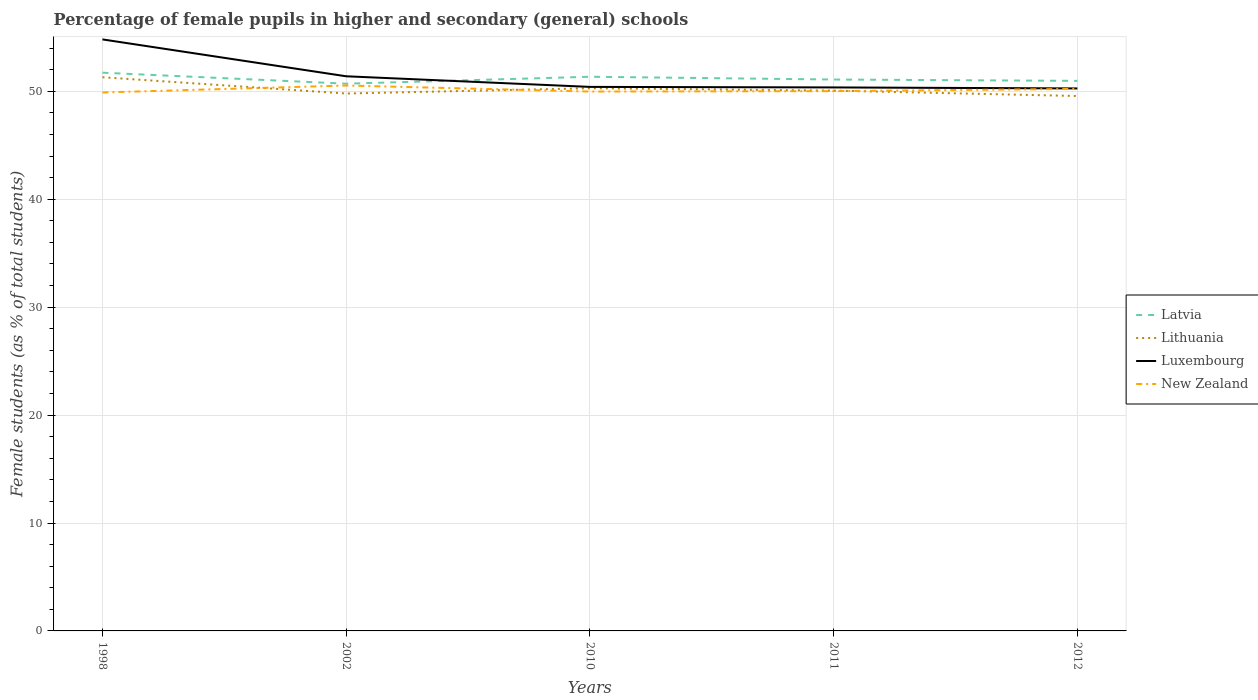How many different coloured lines are there?
Offer a terse response. 4. Does the line corresponding to Lithuania intersect with the line corresponding to Luxembourg?
Ensure brevity in your answer.  No. Across all years, what is the maximum percentage of female pupils in higher and secondary schools in Latvia?
Provide a succinct answer. 50.71. What is the total percentage of female pupils in higher and secondary schools in Latvia in the graph?
Your response must be concise. 0.38. What is the difference between the highest and the second highest percentage of female pupils in higher and secondary schools in New Zealand?
Your response must be concise. 0.65. How many lines are there?
Your answer should be compact. 4. How many years are there in the graph?
Provide a short and direct response. 5. Does the graph contain any zero values?
Provide a short and direct response. No. How are the legend labels stacked?
Ensure brevity in your answer.  Vertical. What is the title of the graph?
Provide a succinct answer. Percentage of female pupils in higher and secondary (general) schools. What is the label or title of the X-axis?
Give a very brief answer. Years. What is the label or title of the Y-axis?
Keep it short and to the point. Female students (as % of total students). What is the Female students (as % of total students) of Latvia in 1998?
Provide a succinct answer. 51.73. What is the Female students (as % of total students) in Lithuania in 1998?
Provide a succinct answer. 51.31. What is the Female students (as % of total students) in Luxembourg in 1998?
Give a very brief answer. 54.81. What is the Female students (as % of total students) of New Zealand in 1998?
Keep it short and to the point. 49.89. What is the Female students (as % of total students) of Latvia in 2002?
Ensure brevity in your answer.  50.71. What is the Female students (as % of total students) of Lithuania in 2002?
Make the answer very short. 49.8. What is the Female students (as % of total students) of Luxembourg in 2002?
Your answer should be compact. 51.39. What is the Female students (as % of total students) of New Zealand in 2002?
Ensure brevity in your answer.  50.54. What is the Female students (as % of total students) in Latvia in 2010?
Offer a terse response. 51.35. What is the Female students (as % of total students) of Lithuania in 2010?
Provide a short and direct response. 50.29. What is the Female students (as % of total students) of Luxembourg in 2010?
Ensure brevity in your answer.  50.41. What is the Female students (as % of total students) in New Zealand in 2010?
Your answer should be very brief. 49.98. What is the Female students (as % of total students) in Latvia in 2011?
Your answer should be compact. 51.09. What is the Female students (as % of total students) in Lithuania in 2011?
Offer a very short reply. 50.06. What is the Female students (as % of total students) in Luxembourg in 2011?
Your answer should be compact. 50.36. What is the Female students (as % of total students) in New Zealand in 2011?
Offer a very short reply. 50.02. What is the Female students (as % of total students) of Latvia in 2012?
Your response must be concise. 50.97. What is the Female students (as % of total students) of Lithuania in 2012?
Offer a very short reply. 49.56. What is the Female students (as % of total students) in Luxembourg in 2012?
Make the answer very short. 50.27. What is the Female students (as % of total students) of New Zealand in 2012?
Make the answer very short. 50.22. Across all years, what is the maximum Female students (as % of total students) in Latvia?
Your answer should be compact. 51.73. Across all years, what is the maximum Female students (as % of total students) of Lithuania?
Offer a terse response. 51.31. Across all years, what is the maximum Female students (as % of total students) of Luxembourg?
Your response must be concise. 54.81. Across all years, what is the maximum Female students (as % of total students) of New Zealand?
Provide a succinct answer. 50.54. Across all years, what is the minimum Female students (as % of total students) of Latvia?
Provide a short and direct response. 50.71. Across all years, what is the minimum Female students (as % of total students) in Lithuania?
Your answer should be very brief. 49.56. Across all years, what is the minimum Female students (as % of total students) in Luxembourg?
Your response must be concise. 50.27. Across all years, what is the minimum Female students (as % of total students) of New Zealand?
Give a very brief answer. 49.89. What is the total Female students (as % of total students) of Latvia in the graph?
Offer a very short reply. 255.84. What is the total Female students (as % of total students) of Lithuania in the graph?
Offer a terse response. 251.02. What is the total Female students (as % of total students) in Luxembourg in the graph?
Offer a very short reply. 257.24. What is the total Female students (as % of total students) of New Zealand in the graph?
Make the answer very short. 250.65. What is the difference between the Female students (as % of total students) of Latvia in 1998 and that in 2002?
Ensure brevity in your answer.  1.02. What is the difference between the Female students (as % of total students) in Lithuania in 1998 and that in 2002?
Give a very brief answer. 1.51. What is the difference between the Female students (as % of total students) in Luxembourg in 1998 and that in 2002?
Your answer should be very brief. 3.42. What is the difference between the Female students (as % of total students) of New Zealand in 1998 and that in 2002?
Make the answer very short. -0.65. What is the difference between the Female students (as % of total students) in Latvia in 1998 and that in 2010?
Give a very brief answer. 0.38. What is the difference between the Female students (as % of total students) in Lithuania in 1998 and that in 2010?
Ensure brevity in your answer.  1.02. What is the difference between the Female students (as % of total students) in Luxembourg in 1998 and that in 2010?
Offer a very short reply. 4.4. What is the difference between the Female students (as % of total students) in New Zealand in 1998 and that in 2010?
Your answer should be very brief. -0.09. What is the difference between the Female students (as % of total students) of Latvia in 1998 and that in 2011?
Keep it short and to the point. 0.63. What is the difference between the Female students (as % of total students) of Lithuania in 1998 and that in 2011?
Offer a terse response. 1.24. What is the difference between the Female students (as % of total students) of Luxembourg in 1998 and that in 2011?
Provide a succinct answer. 4.45. What is the difference between the Female students (as % of total students) of New Zealand in 1998 and that in 2011?
Keep it short and to the point. -0.12. What is the difference between the Female students (as % of total students) in Latvia in 1998 and that in 2012?
Your response must be concise. 0.76. What is the difference between the Female students (as % of total students) of Lithuania in 1998 and that in 2012?
Provide a short and direct response. 1.74. What is the difference between the Female students (as % of total students) in Luxembourg in 1998 and that in 2012?
Ensure brevity in your answer.  4.54. What is the difference between the Female students (as % of total students) in New Zealand in 1998 and that in 2012?
Ensure brevity in your answer.  -0.33. What is the difference between the Female students (as % of total students) of Latvia in 2002 and that in 2010?
Offer a very short reply. -0.64. What is the difference between the Female students (as % of total students) in Lithuania in 2002 and that in 2010?
Provide a succinct answer. -0.49. What is the difference between the Female students (as % of total students) of Luxembourg in 2002 and that in 2010?
Give a very brief answer. 0.98. What is the difference between the Female students (as % of total students) in New Zealand in 2002 and that in 2010?
Provide a succinct answer. 0.56. What is the difference between the Female students (as % of total students) of Latvia in 2002 and that in 2011?
Your response must be concise. -0.39. What is the difference between the Female students (as % of total students) of Lithuania in 2002 and that in 2011?
Ensure brevity in your answer.  -0.27. What is the difference between the Female students (as % of total students) of Luxembourg in 2002 and that in 2011?
Your answer should be very brief. 1.03. What is the difference between the Female students (as % of total students) in New Zealand in 2002 and that in 2011?
Give a very brief answer. 0.52. What is the difference between the Female students (as % of total students) in Latvia in 2002 and that in 2012?
Your answer should be compact. -0.26. What is the difference between the Female students (as % of total students) of Lithuania in 2002 and that in 2012?
Give a very brief answer. 0.23. What is the difference between the Female students (as % of total students) in Luxembourg in 2002 and that in 2012?
Ensure brevity in your answer.  1.13. What is the difference between the Female students (as % of total students) of New Zealand in 2002 and that in 2012?
Offer a terse response. 0.32. What is the difference between the Female students (as % of total students) in Latvia in 2010 and that in 2011?
Provide a succinct answer. 0.26. What is the difference between the Female students (as % of total students) in Lithuania in 2010 and that in 2011?
Offer a terse response. 0.22. What is the difference between the Female students (as % of total students) of Luxembourg in 2010 and that in 2011?
Make the answer very short. 0.05. What is the difference between the Female students (as % of total students) in New Zealand in 2010 and that in 2011?
Your answer should be very brief. -0.04. What is the difference between the Female students (as % of total students) in Latvia in 2010 and that in 2012?
Keep it short and to the point. 0.38. What is the difference between the Female students (as % of total students) of Lithuania in 2010 and that in 2012?
Offer a terse response. 0.72. What is the difference between the Female students (as % of total students) in Luxembourg in 2010 and that in 2012?
Make the answer very short. 0.14. What is the difference between the Female students (as % of total students) of New Zealand in 2010 and that in 2012?
Provide a succinct answer. -0.24. What is the difference between the Female students (as % of total students) in Latvia in 2011 and that in 2012?
Offer a terse response. 0.12. What is the difference between the Female students (as % of total students) of Lithuania in 2011 and that in 2012?
Offer a terse response. 0.5. What is the difference between the Female students (as % of total students) of Luxembourg in 2011 and that in 2012?
Provide a short and direct response. 0.09. What is the difference between the Female students (as % of total students) in New Zealand in 2011 and that in 2012?
Offer a terse response. -0.21. What is the difference between the Female students (as % of total students) of Latvia in 1998 and the Female students (as % of total students) of Lithuania in 2002?
Offer a terse response. 1.93. What is the difference between the Female students (as % of total students) of Latvia in 1998 and the Female students (as % of total students) of Luxembourg in 2002?
Offer a terse response. 0.33. What is the difference between the Female students (as % of total students) in Latvia in 1998 and the Female students (as % of total students) in New Zealand in 2002?
Provide a short and direct response. 1.19. What is the difference between the Female students (as % of total students) in Lithuania in 1998 and the Female students (as % of total students) in Luxembourg in 2002?
Offer a terse response. -0.09. What is the difference between the Female students (as % of total students) in Lithuania in 1998 and the Female students (as % of total students) in New Zealand in 2002?
Offer a terse response. 0.77. What is the difference between the Female students (as % of total students) of Luxembourg in 1998 and the Female students (as % of total students) of New Zealand in 2002?
Offer a terse response. 4.27. What is the difference between the Female students (as % of total students) in Latvia in 1998 and the Female students (as % of total students) in Lithuania in 2010?
Make the answer very short. 1.44. What is the difference between the Female students (as % of total students) in Latvia in 1998 and the Female students (as % of total students) in Luxembourg in 2010?
Offer a terse response. 1.32. What is the difference between the Female students (as % of total students) in Latvia in 1998 and the Female students (as % of total students) in New Zealand in 2010?
Offer a terse response. 1.75. What is the difference between the Female students (as % of total students) of Lithuania in 1998 and the Female students (as % of total students) of Luxembourg in 2010?
Your response must be concise. 0.9. What is the difference between the Female students (as % of total students) of Lithuania in 1998 and the Female students (as % of total students) of New Zealand in 2010?
Give a very brief answer. 1.33. What is the difference between the Female students (as % of total students) of Luxembourg in 1998 and the Female students (as % of total students) of New Zealand in 2010?
Give a very brief answer. 4.83. What is the difference between the Female students (as % of total students) of Latvia in 1998 and the Female students (as % of total students) of Lithuania in 2011?
Your response must be concise. 1.66. What is the difference between the Female students (as % of total students) of Latvia in 1998 and the Female students (as % of total students) of Luxembourg in 2011?
Make the answer very short. 1.36. What is the difference between the Female students (as % of total students) in Latvia in 1998 and the Female students (as % of total students) in New Zealand in 2011?
Provide a short and direct response. 1.71. What is the difference between the Female students (as % of total students) of Lithuania in 1998 and the Female students (as % of total students) of Luxembourg in 2011?
Offer a terse response. 0.94. What is the difference between the Female students (as % of total students) in Lithuania in 1998 and the Female students (as % of total students) in New Zealand in 2011?
Make the answer very short. 1.29. What is the difference between the Female students (as % of total students) of Luxembourg in 1998 and the Female students (as % of total students) of New Zealand in 2011?
Provide a succinct answer. 4.79. What is the difference between the Female students (as % of total students) of Latvia in 1998 and the Female students (as % of total students) of Lithuania in 2012?
Provide a succinct answer. 2.16. What is the difference between the Female students (as % of total students) in Latvia in 1998 and the Female students (as % of total students) in Luxembourg in 2012?
Your response must be concise. 1.46. What is the difference between the Female students (as % of total students) in Latvia in 1998 and the Female students (as % of total students) in New Zealand in 2012?
Provide a succinct answer. 1.5. What is the difference between the Female students (as % of total students) in Lithuania in 1998 and the Female students (as % of total students) in Luxembourg in 2012?
Keep it short and to the point. 1.04. What is the difference between the Female students (as % of total students) of Lithuania in 1998 and the Female students (as % of total students) of New Zealand in 2012?
Offer a very short reply. 1.08. What is the difference between the Female students (as % of total students) of Luxembourg in 1998 and the Female students (as % of total students) of New Zealand in 2012?
Your answer should be compact. 4.59. What is the difference between the Female students (as % of total students) of Latvia in 2002 and the Female students (as % of total students) of Lithuania in 2010?
Offer a terse response. 0.42. What is the difference between the Female students (as % of total students) of Latvia in 2002 and the Female students (as % of total students) of Luxembourg in 2010?
Keep it short and to the point. 0.3. What is the difference between the Female students (as % of total students) of Latvia in 2002 and the Female students (as % of total students) of New Zealand in 2010?
Your answer should be very brief. 0.73. What is the difference between the Female students (as % of total students) in Lithuania in 2002 and the Female students (as % of total students) in Luxembourg in 2010?
Provide a short and direct response. -0.61. What is the difference between the Female students (as % of total students) in Lithuania in 2002 and the Female students (as % of total students) in New Zealand in 2010?
Make the answer very short. -0.18. What is the difference between the Female students (as % of total students) in Luxembourg in 2002 and the Female students (as % of total students) in New Zealand in 2010?
Provide a succinct answer. 1.41. What is the difference between the Female students (as % of total students) in Latvia in 2002 and the Female students (as % of total students) in Lithuania in 2011?
Make the answer very short. 0.64. What is the difference between the Female students (as % of total students) in Latvia in 2002 and the Female students (as % of total students) in Luxembourg in 2011?
Your answer should be very brief. 0.35. What is the difference between the Female students (as % of total students) of Latvia in 2002 and the Female students (as % of total students) of New Zealand in 2011?
Provide a short and direct response. 0.69. What is the difference between the Female students (as % of total students) in Lithuania in 2002 and the Female students (as % of total students) in Luxembourg in 2011?
Give a very brief answer. -0.57. What is the difference between the Female students (as % of total students) in Lithuania in 2002 and the Female students (as % of total students) in New Zealand in 2011?
Your answer should be very brief. -0.22. What is the difference between the Female students (as % of total students) in Luxembourg in 2002 and the Female students (as % of total students) in New Zealand in 2011?
Your response must be concise. 1.38. What is the difference between the Female students (as % of total students) in Latvia in 2002 and the Female students (as % of total students) in Lithuania in 2012?
Ensure brevity in your answer.  1.14. What is the difference between the Female students (as % of total students) in Latvia in 2002 and the Female students (as % of total students) in Luxembourg in 2012?
Ensure brevity in your answer.  0.44. What is the difference between the Female students (as % of total students) in Latvia in 2002 and the Female students (as % of total students) in New Zealand in 2012?
Ensure brevity in your answer.  0.48. What is the difference between the Female students (as % of total students) in Lithuania in 2002 and the Female students (as % of total students) in Luxembourg in 2012?
Your answer should be compact. -0.47. What is the difference between the Female students (as % of total students) of Lithuania in 2002 and the Female students (as % of total students) of New Zealand in 2012?
Ensure brevity in your answer.  -0.43. What is the difference between the Female students (as % of total students) in Luxembourg in 2002 and the Female students (as % of total students) in New Zealand in 2012?
Offer a terse response. 1.17. What is the difference between the Female students (as % of total students) of Latvia in 2010 and the Female students (as % of total students) of Lithuania in 2011?
Make the answer very short. 1.29. What is the difference between the Female students (as % of total students) in Latvia in 2010 and the Female students (as % of total students) in New Zealand in 2011?
Make the answer very short. 1.33. What is the difference between the Female students (as % of total students) of Lithuania in 2010 and the Female students (as % of total students) of Luxembourg in 2011?
Your answer should be compact. -0.07. What is the difference between the Female students (as % of total students) in Lithuania in 2010 and the Female students (as % of total students) in New Zealand in 2011?
Your answer should be compact. 0.27. What is the difference between the Female students (as % of total students) in Luxembourg in 2010 and the Female students (as % of total students) in New Zealand in 2011?
Give a very brief answer. 0.39. What is the difference between the Female students (as % of total students) of Latvia in 2010 and the Female students (as % of total students) of Lithuania in 2012?
Your answer should be very brief. 1.78. What is the difference between the Female students (as % of total students) of Latvia in 2010 and the Female students (as % of total students) of Luxembourg in 2012?
Offer a terse response. 1.08. What is the difference between the Female students (as % of total students) in Latvia in 2010 and the Female students (as % of total students) in New Zealand in 2012?
Offer a terse response. 1.13. What is the difference between the Female students (as % of total students) in Lithuania in 2010 and the Female students (as % of total students) in Luxembourg in 2012?
Keep it short and to the point. 0.02. What is the difference between the Female students (as % of total students) in Lithuania in 2010 and the Female students (as % of total students) in New Zealand in 2012?
Your answer should be very brief. 0.06. What is the difference between the Female students (as % of total students) in Luxembourg in 2010 and the Female students (as % of total students) in New Zealand in 2012?
Keep it short and to the point. 0.19. What is the difference between the Female students (as % of total students) of Latvia in 2011 and the Female students (as % of total students) of Lithuania in 2012?
Your response must be concise. 1.53. What is the difference between the Female students (as % of total students) in Latvia in 2011 and the Female students (as % of total students) in Luxembourg in 2012?
Give a very brief answer. 0.83. What is the difference between the Female students (as % of total students) in Latvia in 2011 and the Female students (as % of total students) in New Zealand in 2012?
Your answer should be compact. 0.87. What is the difference between the Female students (as % of total students) of Lithuania in 2011 and the Female students (as % of total students) of Luxembourg in 2012?
Offer a very short reply. -0.2. What is the difference between the Female students (as % of total students) in Lithuania in 2011 and the Female students (as % of total students) in New Zealand in 2012?
Make the answer very short. -0.16. What is the difference between the Female students (as % of total students) of Luxembourg in 2011 and the Female students (as % of total students) of New Zealand in 2012?
Your answer should be very brief. 0.14. What is the average Female students (as % of total students) in Latvia per year?
Provide a short and direct response. 51.17. What is the average Female students (as % of total students) in Lithuania per year?
Your answer should be very brief. 50.2. What is the average Female students (as % of total students) in Luxembourg per year?
Offer a terse response. 51.45. What is the average Female students (as % of total students) of New Zealand per year?
Your answer should be very brief. 50.13. In the year 1998, what is the difference between the Female students (as % of total students) of Latvia and Female students (as % of total students) of Lithuania?
Keep it short and to the point. 0.42. In the year 1998, what is the difference between the Female students (as % of total students) in Latvia and Female students (as % of total students) in Luxembourg?
Provide a succinct answer. -3.08. In the year 1998, what is the difference between the Female students (as % of total students) in Latvia and Female students (as % of total students) in New Zealand?
Provide a short and direct response. 1.83. In the year 1998, what is the difference between the Female students (as % of total students) in Lithuania and Female students (as % of total students) in Luxembourg?
Offer a very short reply. -3.5. In the year 1998, what is the difference between the Female students (as % of total students) of Lithuania and Female students (as % of total students) of New Zealand?
Ensure brevity in your answer.  1.41. In the year 1998, what is the difference between the Female students (as % of total students) in Luxembourg and Female students (as % of total students) in New Zealand?
Provide a succinct answer. 4.92. In the year 2002, what is the difference between the Female students (as % of total students) in Latvia and Female students (as % of total students) in Lithuania?
Your answer should be very brief. 0.91. In the year 2002, what is the difference between the Female students (as % of total students) in Latvia and Female students (as % of total students) in Luxembourg?
Your answer should be very brief. -0.69. In the year 2002, what is the difference between the Female students (as % of total students) in Latvia and Female students (as % of total students) in New Zealand?
Your response must be concise. 0.17. In the year 2002, what is the difference between the Female students (as % of total students) in Lithuania and Female students (as % of total students) in Luxembourg?
Your answer should be compact. -1.6. In the year 2002, what is the difference between the Female students (as % of total students) of Lithuania and Female students (as % of total students) of New Zealand?
Give a very brief answer. -0.74. In the year 2002, what is the difference between the Female students (as % of total students) in Luxembourg and Female students (as % of total students) in New Zealand?
Provide a short and direct response. 0.85. In the year 2010, what is the difference between the Female students (as % of total students) of Latvia and Female students (as % of total students) of Lithuania?
Your response must be concise. 1.06. In the year 2010, what is the difference between the Female students (as % of total students) of Latvia and Female students (as % of total students) of Luxembourg?
Offer a terse response. 0.94. In the year 2010, what is the difference between the Female students (as % of total students) in Latvia and Female students (as % of total students) in New Zealand?
Provide a succinct answer. 1.37. In the year 2010, what is the difference between the Female students (as % of total students) of Lithuania and Female students (as % of total students) of Luxembourg?
Your answer should be compact. -0.12. In the year 2010, what is the difference between the Female students (as % of total students) in Lithuania and Female students (as % of total students) in New Zealand?
Keep it short and to the point. 0.31. In the year 2010, what is the difference between the Female students (as % of total students) in Luxembourg and Female students (as % of total students) in New Zealand?
Give a very brief answer. 0.43. In the year 2011, what is the difference between the Female students (as % of total students) of Latvia and Female students (as % of total students) of Lithuania?
Give a very brief answer. 1.03. In the year 2011, what is the difference between the Female students (as % of total students) of Latvia and Female students (as % of total students) of Luxembourg?
Offer a terse response. 0.73. In the year 2011, what is the difference between the Female students (as % of total students) of Latvia and Female students (as % of total students) of New Zealand?
Keep it short and to the point. 1.08. In the year 2011, what is the difference between the Female students (as % of total students) of Lithuania and Female students (as % of total students) of Luxembourg?
Ensure brevity in your answer.  -0.3. In the year 2011, what is the difference between the Female students (as % of total students) of Lithuania and Female students (as % of total students) of New Zealand?
Make the answer very short. 0.05. In the year 2011, what is the difference between the Female students (as % of total students) of Luxembourg and Female students (as % of total students) of New Zealand?
Provide a succinct answer. 0.35. In the year 2012, what is the difference between the Female students (as % of total students) of Latvia and Female students (as % of total students) of Lithuania?
Ensure brevity in your answer.  1.4. In the year 2012, what is the difference between the Female students (as % of total students) of Latvia and Female students (as % of total students) of Luxembourg?
Offer a very short reply. 0.7. In the year 2012, what is the difference between the Female students (as % of total students) in Latvia and Female students (as % of total students) in New Zealand?
Ensure brevity in your answer.  0.74. In the year 2012, what is the difference between the Female students (as % of total students) in Lithuania and Female students (as % of total students) in Luxembourg?
Offer a terse response. -0.7. In the year 2012, what is the difference between the Female students (as % of total students) of Lithuania and Female students (as % of total students) of New Zealand?
Provide a succinct answer. -0.66. In the year 2012, what is the difference between the Female students (as % of total students) in Luxembourg and Female students (as % of total students) in New Zealand?
Give a very brief answer. 0.04. What is the ratio of the Female students (as % of total students) of Latvia in 1998 to that in 2002?
Your answer should be very brief. 1.02. What is the ratio of the Female students (as % of total students) in Lithuania in 1998 to that in 2002?
Keep it short and to the point. 1.03. What is the ratio of the Female students (as % of total students) of Luxembourg in 1998 to that in 2002?
Offer a terse response. 1.07. What is the ratio of the Female students (as % of total students) of New Zealand in 1998 to that in 2002?
Provide a succinct answer. 0.99. What is the ratio of the Female students (as % of total students) in Latvia in 1998 to that in 2010?
Provide a short and direct response. 1.01. What is the ratio of the Female students (as % of total students) in Lithuania in 1998 to that in 2010?
Your answer should be very brief. 1.02. What is the ratio of the Female students (as % of total students) of Luxembourg in 1998 to that in 2010?
Your answer should be very brief. 1.09. What is the ratio of the Female students (as % of total students) in New Zealand in 1998 to that in 2010?
Give a very brief answer. 1. What is the ratio of the Female students (as % of total students) of Latvia in 1998 to that in 2011?
Keep it short and to the point. 1.01. What is the ratio of the Female students (as % of total students) of Lithuania in 1998 to that in 2011?
Your response must be concise. 1.02. What is the ratio of the Female students (as % of total students) of Luxembourg in 1998 to that in 2011?
Provide a succinct answer. 1.09. What is the ratio of the Female students (as % of total students) of Latvia in 1998 to that in 2012?
Your response must be concise. 1.01. What is the ratio of the Female students (as % of total students) in Lithuania in 1998 to that in 2012?
Provide a succinct answer. 1.04. What is the ratio of the Female students (as % of total students) of Luxembourg in 1998 to that in 2012?
Your answer should be very brief. 1.09. What is the ratio of the Female students (as % of total students) in New Zealand in 1998 to that in 2012?
Your response must be concise. 0.99. What is the ratio of the Female students (as % of total students) of Latvia in 2002 to that in 2010?
Provide a succinct answer. 0.99. What is the ratio of the Female students (as % of total students) in Lithuania in 2002 to that in 2010?
Ensure brevity in your answer.  0.99. What is the ratio of the Female students (as % of total students) in Luxembourg in 2002 to that in 2010?
Your response must be concise. 1.02. What is the ratio of the Female students (as % of total students) of New Zealand in 2002 to that in 2010?
Offer a terse response. 1.01. What is the ratio of the Female students (as % of total students) of Latvia in 2002 to that in 2011?
Your answer should be compact. 0.99. What is the ratio of the Female students (as % of total students) of Luxembourg in 2002 to that in 2011?
Give a very brief answer. 1.02. What is the ratio of the Female students (as % of total students) of New Zealand in 2002 to that in 2011?
Ensure brevity in your answer.  1.01. What is the ratio of the Female students (as % of total students) of Latvia in 2002 to that in 2012?
Provide a succinct answer. 0.99. What is the ratio of the Female students (as % of total students) of Luxembourg in 2002 to that in 2012?
Offer a very short reply. 1.02. What is the ratio of the Female students (as % of total students) in New Zealand in 2002 to that in 2012?
Your response must be concise. 1.01. What is the ratio of the Female students (as % of total students) of Lithuania in 2010 to that in 2011?
Offer a terse response. 1. What is the ratio of the Female students (as % of total students) in Luxembourg in 2010 to that in 2011?
Offer a very short reply. 1. What is the ratio of the Female students (as % of total students) in New Zealand in 2010 to that in 2011?
Provide a short and direct response. 1. What is the ratio of the Female students (as % of total students) of Latvia in 2010 to that in 2012?
Your answer should be compact. 1.01. What is the ratio of the Female students (as % of total students) of Lithuania in 2010 to that in 2012?
Offer a terse response. 1.01. What is the ratio of the Female students (as % of total students) of Luxembourg in 2010 to that in 2012?
Your answer should be very brief. 1. What is the difference between the highest and the second highest Female students (as % of total students) of Latvia?
Ensure brevity in your answer.  0.38. What is the difference between the highest and the second highest Female students (as % of total students) of Lithuania?
Keep it short and to the point. 1.02. What is the difference between the highest and the second highest Female students (as % of total students) of Luxembourg?
Provide a succinct answer. 3.42. What is the difference between the highest and the second highest Female students (as % of total students) in New Zealand?
Provide a short and direct response. 0.32. What is the difference between the highest and the lowest Female students (as % of total students) of Latvia?
Your answer should be compact. 1.02. What is the difference between the highest and the lowest Female students (as % of total students) in Lithuania?
Your answer should be very brief. 1.74. What is the difference between the highest and the lowest Female students (as % of total students) in Luxembourg?
Offer a terse response. 4.54. What is the difference between the highest and the lowest Female students (as % of total students) in New Zealand?
Your answer should be very brief. 0.65. 